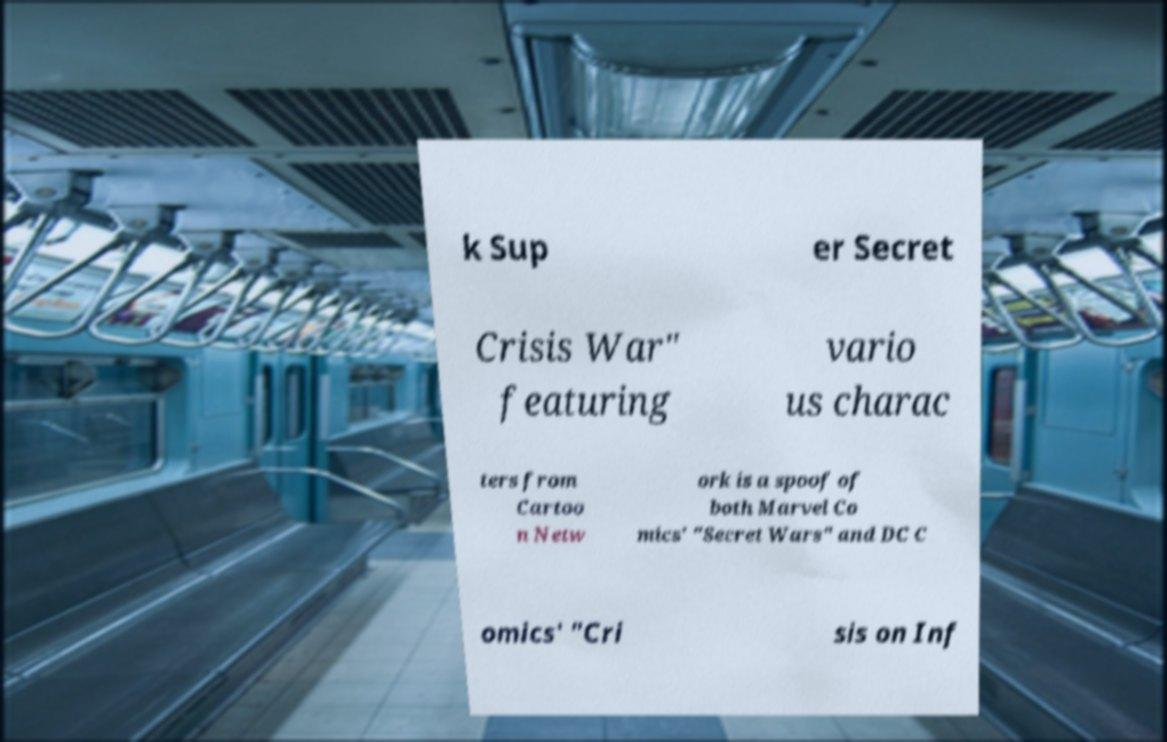There's text embedded in this image that I need extracted. Can you transcribe it verbatim? k Sup er Secret Crisis War" featuring vario us charac ters from Cartoo n Netw ork is a spoof of both Marvel Co mics' "Secret Wars" and DC C omics' "Cri sis on Inf 